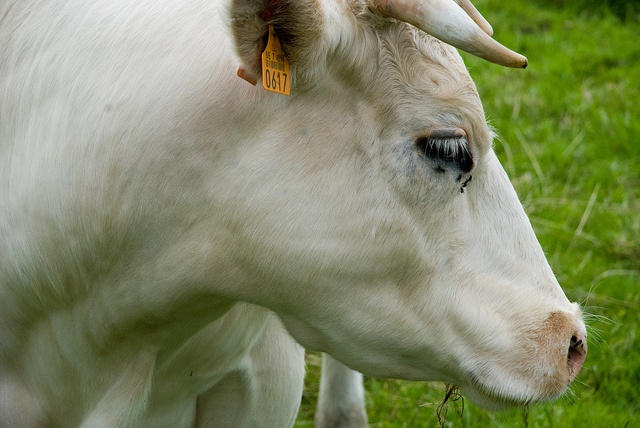Describe the objects in this image and their specific colors. I can see a cow in darkgray, gray, and darkgreen tones in this image. 